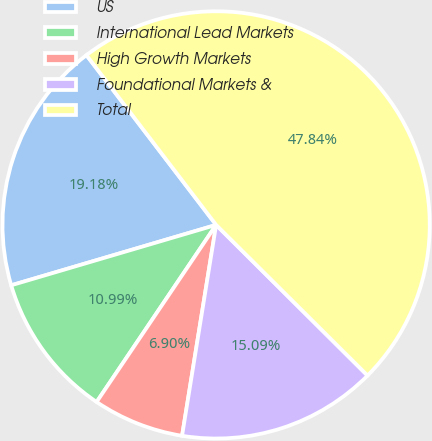Convert chart. <chart><loc_0><loc_0><loc_500><loc_500><pie_chart><fcel>US<fcel>International Lead Markets<fcel>High Growth Markets<fcel>Foundational Markets &<fcel>Total<nl><fcel>19.18%<fcel>10.99%<fcel>6.9%<fcel>15.09%<fcel>47.84%<nl></chart> 